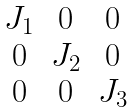<formula> <loc_0><loc_0><loc_500><loc_500>\begin{matrix} J _ { 1 } & 0 & 0 \\ 0 & J _ { 2 } & 0 \\ 0 & 0 & J _ { 3 } \end{matrix}</formula> 